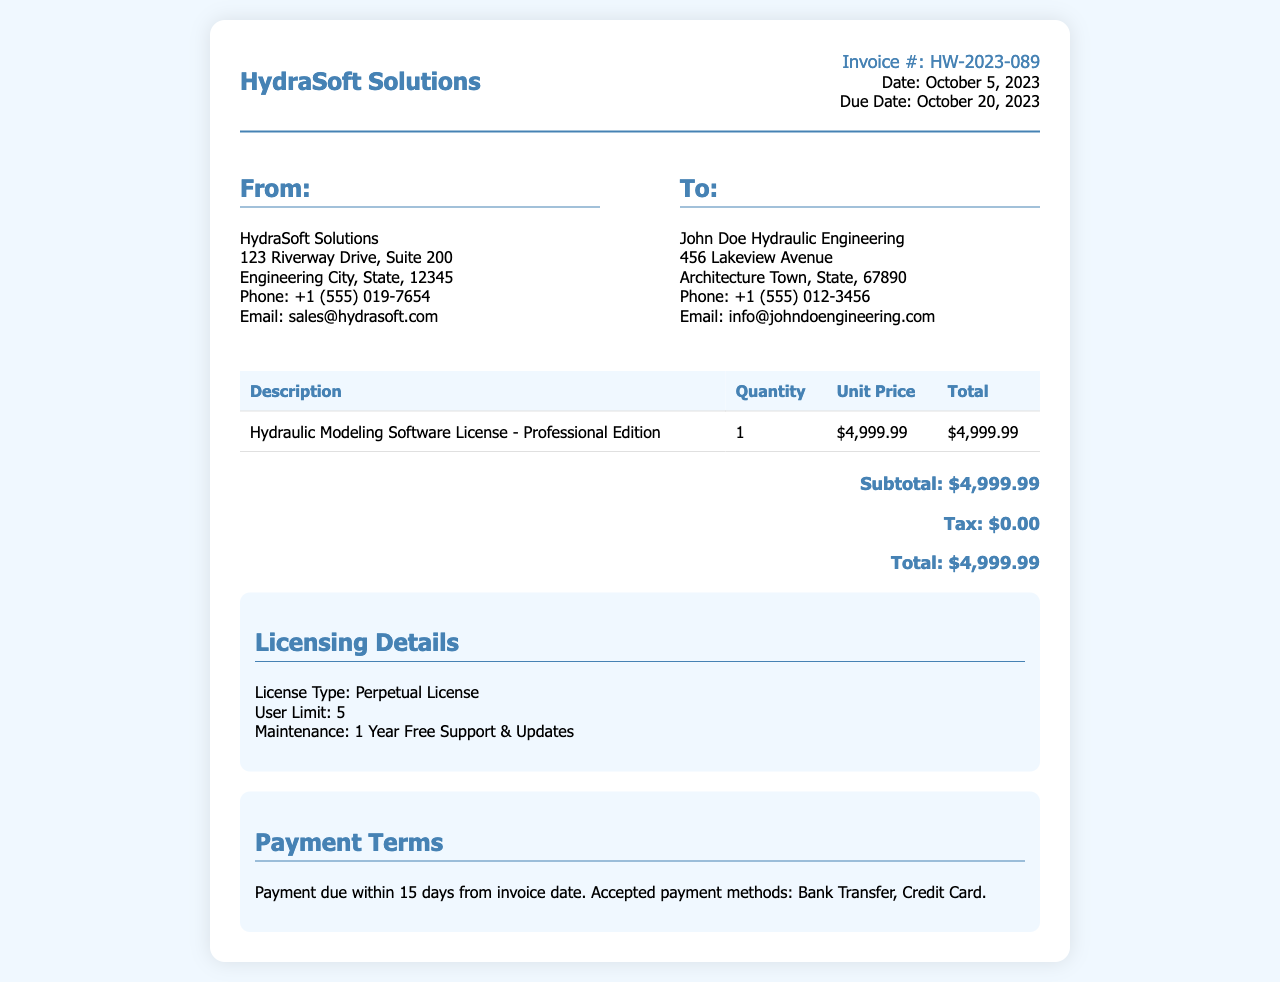What is the invoice number? The invoice number is listed at the top right of the document under invoice details.
Answer: HW-2023-089 What is the total amount due? The total amount due is calculated at the bottom of the receipt after adding any applicable tax.
Answer: $4,999.99 Who is the recipient of the invoice? The recipient's details are listed in the "To" section of the document.
Answer: John Doe Hydraulic Engineering What is the due date for the payment? The due date is mentioned in the invoice details section.
Answer: October 20, 2023 What type of license is offered? The licensing details state the type of license provided for the software.
Answer: Perpetual License How many users can access the software? The user limit is specified in the licensing details section.
Answer: 5 What are the accepted payment methods? Accepted payment methods are outlined in the payment terms section.
Answer: Bank Transfer, Credit Card What is the subtotal before tax? The subtotal is presented before any tax and is detailed in the total section.
Answer: $4,999.99 For how long is maintenance provided? The maintenance period is noted in the licensing details provided in the document.
Answer: 1 Year Free Support & Updates 